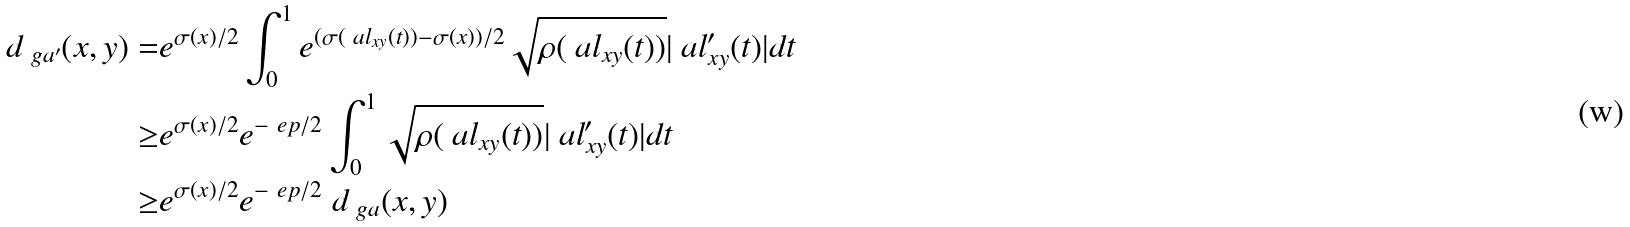Convert formula to latex. <formula><loc_0><loc_0><loc_500><loc_500>d _ { \ g a ^ { \prime } } ( x , y ) = & e ^ { \sigma ( x ) / 2 } \int _ { 0 } ^ { 1 } e ^ { ( \sigma ( \ a l _ { x y } ( t ) ) - \sigma ( x ) ) / 2 } \sqrt { \rho ( \ a l _ { x y } ( t ) ) } | \ a l ^ { \prime } _ { x y } ( t ) | d t \\ \geq & e ^ { \sigma ( x ) / 2 } e ^ { - \ e p / 2 } \int _ { 0 } ^ { 1 } \sqrt { \rho ( \ a l _ { x y } ( t ) ) } | \ a l ^ { \prime } _ { x y } ( t ) | d t \\ \geq & e ^ { \sigma ( x ) / 2 } e ^ { - \ e p / 2 } \ d _ { \ g a } ( x , y ) \\</formula> 